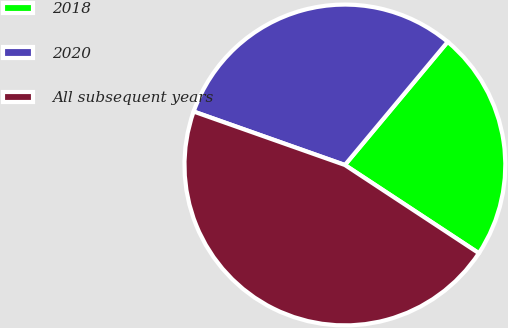Convert chart. <chart><loc_0><loc_0><loc_500><loc_500><pie_chart><fcel>2018<fcel>2020<fcel>All subsequent years<nl><fcel>23.2%<fcel>30.66%<fcel>46.14%<nl></chart> 